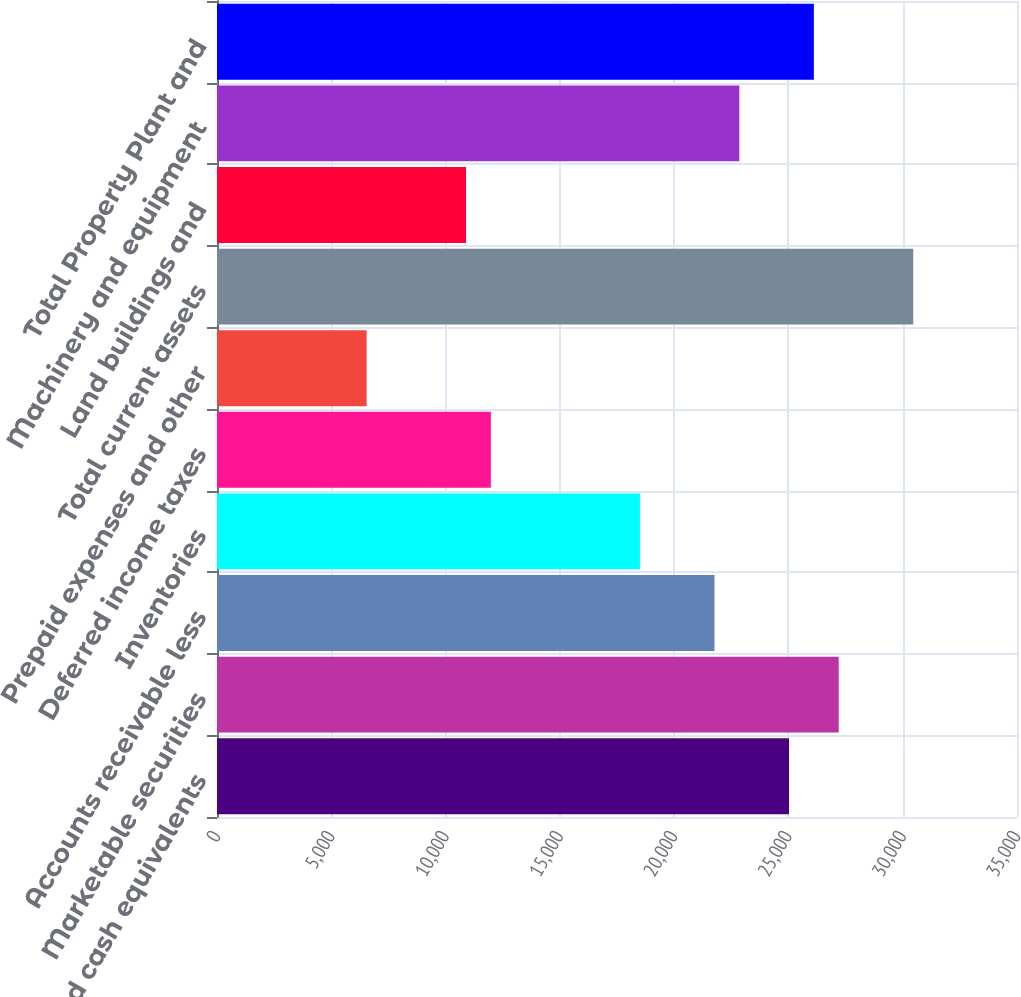Convert chart to OTSL. <chart><loc_0><loc_0><loc_500><loc_500><bar_chart><fcel>Cash and cash equivalents<fcel>Marketable securities<fcel>Accounts receivable less<fcel>Inventories<fcel>Deferred income taxes<fcel>Prepaid expenses and other<fcel>Total current assets<fcel>Land buildings and<fcel>Machinery and equipment<fcel>Total Property Plant and<nl><fcel>25025.8<fcel>27199.8<fcel>21764.9<fcel>18504<fcel>11982.1<fcel>6547.18<fcel>30460.7<fcel>10895.1<fcel>22851.9<fcel>26112.8<nl></chart> 